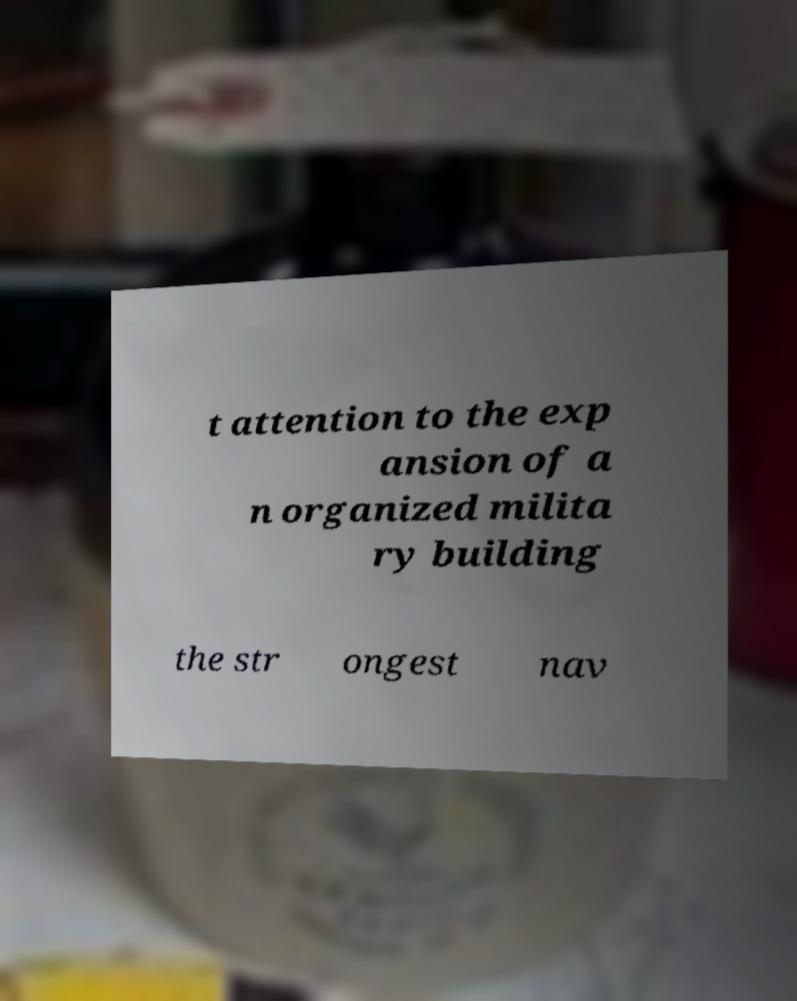For documentation purposes, I need the text within this image transcribed. Could you provide that? t attention to the exp ansion of a n organized milita ry building the str ongest nav 